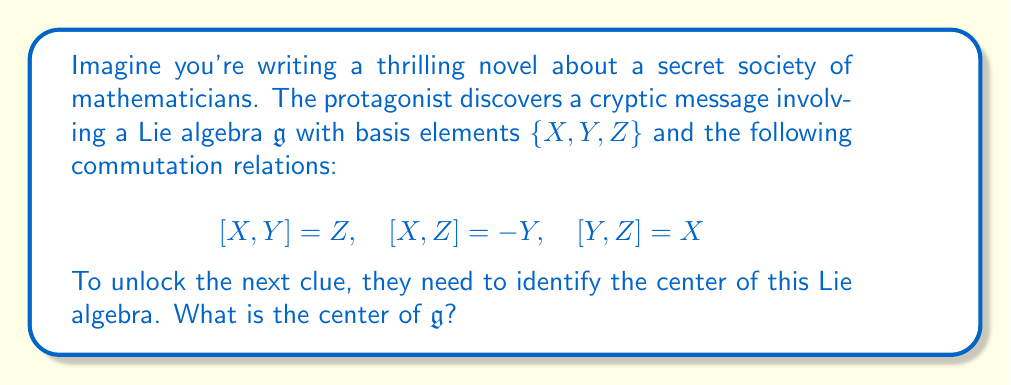Provide a solution to this math problem. To find the center of the Lie algebra $\mathfrak{g}$, we need to determine which elements commute with all other elements. Let's approach this step-by-step:

1) First, let's consider a general element of $\mathfrak{g}$:
   $W = aX + bY + cZ$, where $a, b, c$ are real numbers.

2) For $W$ to be in the center, it must commute with all basis elements. Let's check each:

   a) $[W,X] = a[X,X] + b[Y,X] + c[Z,X]$
              $= 0 - bZ + cY$
              $= cY - bZ$

   b) $[W,Y] = a[X,Y] + b[Y,Y] + c[Z,Y]$
              $= aZ + 0 - cX$
              $= aZ - cX$

   c) $[W,Z] = a[X,Z] + b[Y,Z] + c[Z,Z]$
              $= -aY + bX + 0$
              $= bX - aY$

3) For $W$ to be in the center, all these commutators must be zero:

   $cY - bZ = 0$
   $aZ - cX = 0$
   $bX - aY = 0$

4) This system of equations is equivalent to:

   $b = c = 0$
   $a = c = 0$
   $a = b = 0$

5) The only solution to this system is $a = b = c = 0$, which means $W = 0$.

Therefore, the only element that commutes with all elements of $\mathfrak{g}$ is the zero element.
Answer: The center of the Lie algebra $\mathfrak{g}$ is $\{0\}$, i.e., it consists only of the zero element. 